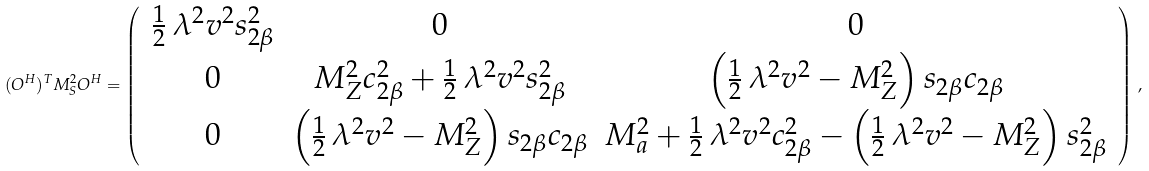Convert formula to latex. <formula><loc_0><loc_0><loc_500><loc_500>( O ^ { H } ) ^ { T } M ^ { 2 } _ { S } O ^ { H } = \left ( \, \begin{array} { c c c } \frac { 1 } { 2 } \, \lambda ^ { 2 } v ^ { 2 } s ^ { 2 } _ { 2 \beta } & 0 & 0 \\ 0 & M ^ { 2 } _ { Z } c ^ { 2 } _ { 2 \beta } + \frac { 1 } { 2 } \, \lambda ^ { 2 } v ^ { 2 } s ^ { 2 } _ { 2 \beta } & \left ( \frac { 1 } { 2 } \, \lambda ^ { 2 } v ^ { 2 } - M ^ { 2 } _ { Z } \right ) s _ { 2 \beta } c _ { 2 \beta } \\ 0 & \left ( \frac { 1 } { 2 } \, \lambda ^ { 2 } v ^ { 2 } - M ^ { 2 } _ { Z } \right ) s _ { 2 \beta } c _ { 2 \beta } & M ^ { 2 } _ { a } + \frac { 1 } { 2 } \, \lambda ^ { 2 } v ^ { 2 } c ^ { 2 } _ { 2 \beta } - \left ( \frac { 1 } { 2 } \, \lambda ^ { 2 } v ^ { 2 } - M ^ { 2 } _ { Z } \right ) s ^ { 2 } _ { 2 \beta } \end{array} \, \right ) \, ,</formula> 